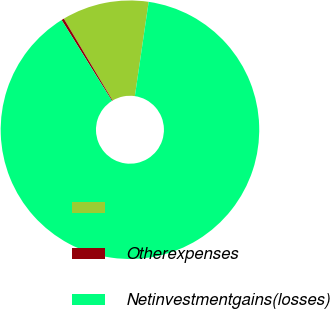Convert chart to OTSL. <chart><loc_0><loc_0><loc_500><loc_500><pie_chart><ecel><fcel>Otherexpenses<fcel>Netinvestmentgains(losses)<nl><fcel>10.86%<fcel>0.32%<fcel>88.82%<nl></chart> 